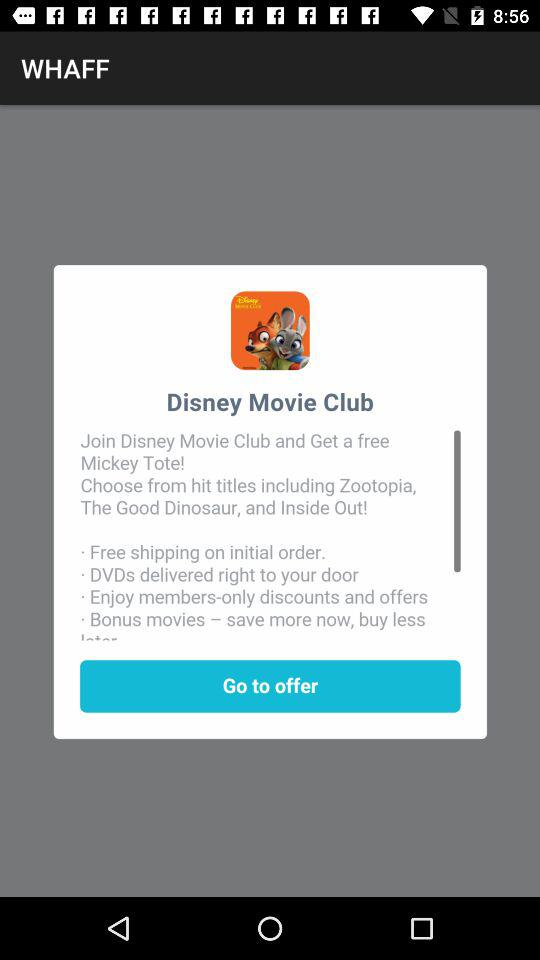What do we get for free by joining "Disney Movie Club"? You get a "Mickey Tote" for free by joining "Disney Movie Club". 